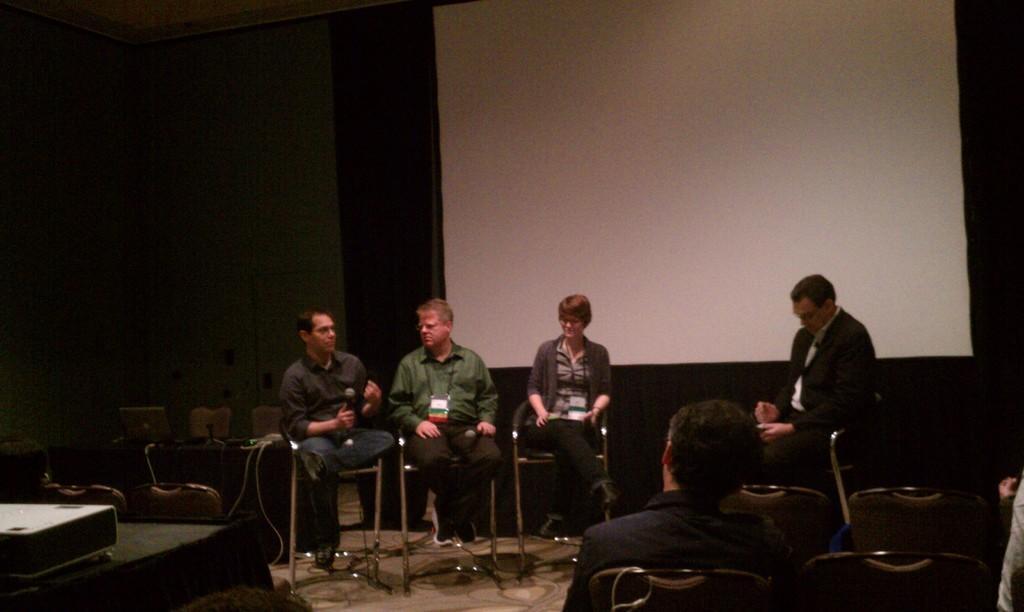Please provide a concise description of this image. Background portion of the picture is dark. In this picture we can see a screen and few objects. We can see the people sitting on the chairs and we can see a man holding a microphone. On the left side of the picture we can see a table and on a table we can see a projector device. 